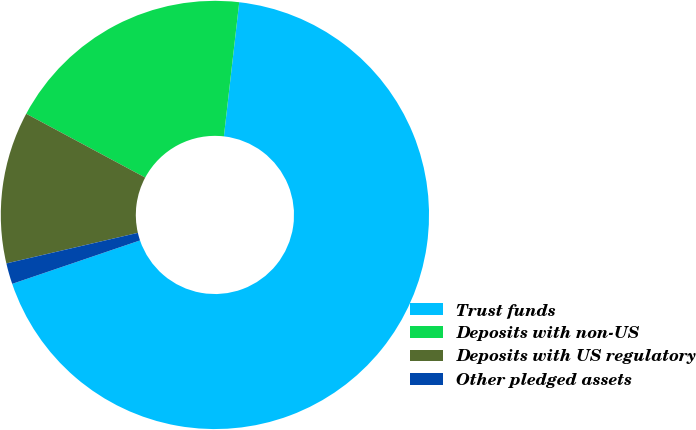Convert chart to OTSL. <chart><loc_0><loc_0><loc_500><loc_500><pie_chart><fcel>Trust funds<fcel>Deposits with non-US<fcel>Deposits with US regulatory<fcel>Other pledged assets<nl><fcel>67.98%<fcel>18.98%<fcel>11.47%<fcel>1.58%<nl></chart> 